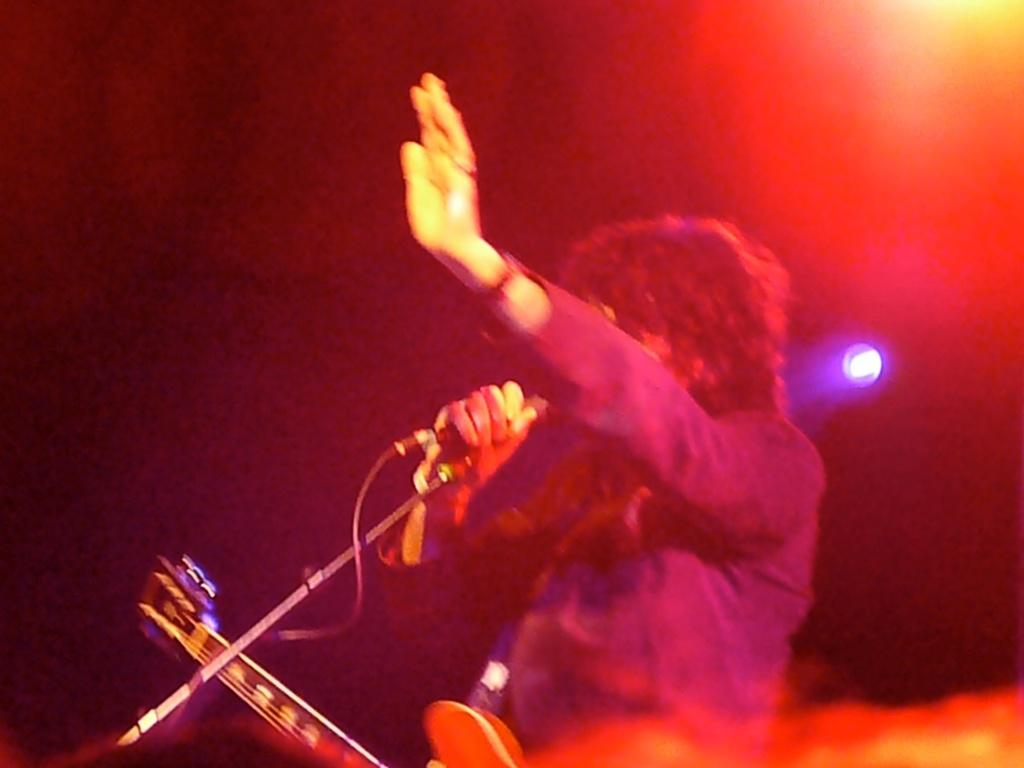What is the person in the image doing? The person is standing in the image and holding a microphone and a wire guitar. What might the person be performing or participating in? The person might be performing or participating in a musical event, given the presence of a microphone and a guitar. What is the lighting condition in the image? The background of the image is dark, but there is light visible in the background. What type of bread can be seen in the image? There is no bread present in the image. How many crows are visible in the image? There are no crows present in the image. 